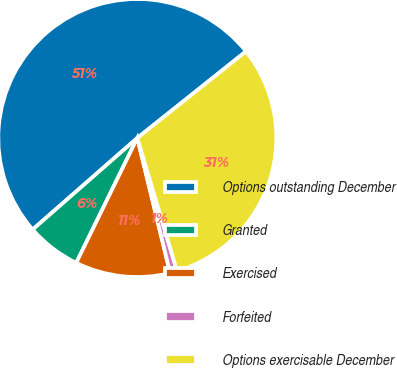Convert chart. <chart><loc_0><loc_0><loc_500><loc_500><pie_chart><fcel>Options outstanding December<fcel>Granted<fcel>Exercised<fcel>Forfeited<fcel>Options exercisable December<nl><fcel>50.73%<fcel>6.32%<fcel>11.04%<fcel>0.82%<fcel>31.09%<nl></chart> 